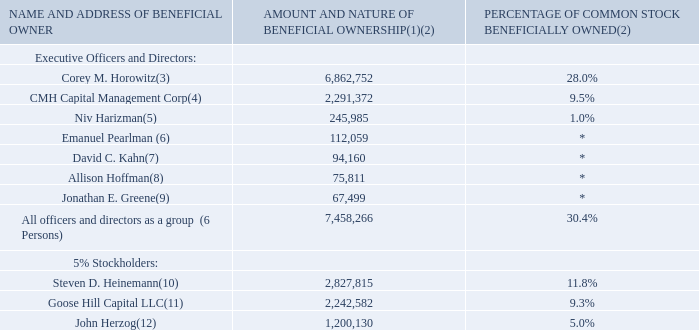ITEM 12. SECURITY OWNERSHIP OF CERTAIN BENEFICIAL OWNERS AND MANAGEMENT AND RELATED STOCKHOLDER MATTERS
The following table sets forth information regarding the beneficial ownership of our common stock as of March 1, 2020 for (i) each of our directors, (ii) each of our executive officers, (iii) each person known by us to be the beneficial owner of more than 5% of our outstanding shares of common stock, and (iv) all of our executive officers and directors as a group.
* Less than 1%.
(1) Unless otherwise indicated, we believe that all persons named in the above table have sole voting and investment power with respect to all shares of our common stock beneficially owned by them. Unless otherwise indicated the address for each listed beneficial owner is c/o Network-1 Technologies, Inc., 445 Park Avenue, Suite 912, New York, New York 10022.
(2) A person is deemed to be the beneficial owner of shares of common stock that can be acquired by such person within 60 days from March 1, 2020 upon the exercise of options or restricted stock units that vest within such 60 day period. Each beneficial owner's percentage ownership is determined by assuming that all stock options and restricted stock units held by such person (but not those held by any other person) and which are exercisable or vested within 60 days from March 1, 2020 have been exercised and vested. Assumes a base of 24,032,941 shares of our common stock outstanding as of March 1, 2020.
(3) Includes (i) 3,549,369 shares of common stock held by Mr. Horowitz, (ii) 500,000 shares of common stock subject to currently exercisable stock options held by Mr. Horowitz, (iii) 2,157,097 shares of common stock held by CMH Capital Management Corp., an entity solely owned by Mr. Horowitz, (iv) 134,275 shares of common stock owned by the CMH Capital Management Corp. Profit Sharing Plan, of which Mr. Horowitz is the trustee, (v) 67,470 shares of common stock owned by Donna Slavitt, the wife of Mr. Horowitz, (vi) an aggregate of 452,250 shares of common stock held by two trusts and a custodian account for the benefit of Mr. Horowitz’s three children, and (vii) 2,291 shares of common stock held by Horowitz Partners, a general partnership of which Mr. Horowitz is a partner. Does not include 250,000 shares of common stock subject to restricted stock units that do not vest within 60 days of March 1, 2020.
(4) Includes 2,157,097 shares of common stock owned by CMH Capital Management Corp. and 134,275 shares of common stock owned by CMH Capital Management Corp. Profit Sharing Plan. Corey M. Horowitz, by virtue of being the sole officer, director and shareholder of CMH Capital Management Corp. and the trustee of the CMH Capital Management Corp. Profit Sharing Plan, has the sole power to vote and dispose of the shares of common stock owned by CMH Capital Management Corp. and the CMH Capital Management Corp. Profit Sharing Plan.
(5) Includes (i) 242,235 shares of common stock and (ii) 3,750 shares of common stock subject to restricted stock units that vest within 60 days of March 1, 2020. Does not include 11,250 shares of common stock subject to restricted stock units that do not vest within 60 days from March 1, 2020.
(6) Includes (i) 108,309 shares of common stock and (ii) 3,750 shares of common stock subject to restricted stock units that vest within 60 days of March 1, 2020. Does not
include 11,250 shares of common stock subject to restricted stock units that do not vest within 60 days from March 1, 2020.
(7) Includes 94,160 shares of common stock. Does not include 27,500 shares of common stock subject to restricted stock units owned by Mr. Kahn that do not vest within 60 days from March 1, 2020.
(8) Includes (i) 72,061 shares of common stock and (ii) 3,750 shares of common stock subject to restricted stock units that vest within 60 days of March 1, 2020. Does not include 11,250 shares of common stock subject to restricted stock units that do not vest within 60 days from March 1, 2020.
(9) Includes 67,499 shares of common stock. Does not include 35,000 shares of common stock subjected to restricted stock units owned by Mr. Greene that do not vest within 60 days from March 1, 2020.
(10) Includes 585,233 shares of common stock owned by Mr. Heinemann and 2,242,582 shares of common stock owned by Goose Hill Capital LLC. Goose Hill Capital LLC is an entity in which Mr. Heinemann is the sole member. Mr. Heinemann, by virtue of being the sole member of Goose Hill Capital LLC, has the sole power to vote and dispose of the shares of common stock owned by Goose Hill Capital LLC. The aforementioned beneficial ownership is based upon Amendment No. 7 to Schedule 13G filed by Mr. Heinemann with the SEC on February 11, 2019. The address for Mr. Heinemann is c/o Goose Hill Capital, LLC, 12378 Indian Road, North Palm Beach, Florida 33408.
(11) Includes 2,242,582 shares of common stock. Steven D. Heinemann, by virtue of being the sole member of Goose Hill Capital LLC, has the sole power to vote and dispose of the shares of common stock owned by Goose Hill Capital LLC. The aforementioned beneficial ownership is based upon Amendment No. 7 to Schedule 13G filed by Mr. Heinemann with the SEC on February 11, 2019. The address for Goose Hill Capital LLC is 12378 Indian Road, North Palm Beach, Florida 33408.
(12) Includes 1,200,130 shares of common stock. The aforementioned beneficial ownership is based upon a Schedule 13G filed by Mr. Herzog with the SEC on February 10, 2016. The address of Mr. Herzog is 824 Harbor Road, Southport, Connecticut 06890-1410.
How is the percentage ownership of common stock determined? By assuming that all stock options and restricted stock units held by such person (but not those held by any other person) and which are exercisable or vested within 60 days from march 1, 2020 have been exercised and vested. What is the total amount and nature of beneficial ownership for all officers and directors as a group? 7,458,266. Who is the sole member of CMH Capital Management Corp. and who is the sole member of Goose Hill Capital LLC.? Corey m. horowitz, mr. heinemann. How many executive officers and directors own less than 100,000 in nature of beneficial ownership? David C. Kahn##Allison Hoffman##Jonathan E. Greene
Answer: 3. What is the percentage of amount and nature of beneficial ownership for John Herzog among the 5% Stockholders?
Answer scale should be: percent. 1,200,130 / (1,200,130 + 2,242,582 + 2,827,815)  
Answer: 19.14. How much more do all officers and directors as a group have in amount and nature of beneficial ownership as compared to the 5% Stockholders? 7,458,266 - (1,200,130 + 2,242,582 + 2,827,815)  
Answer: 1187739. 